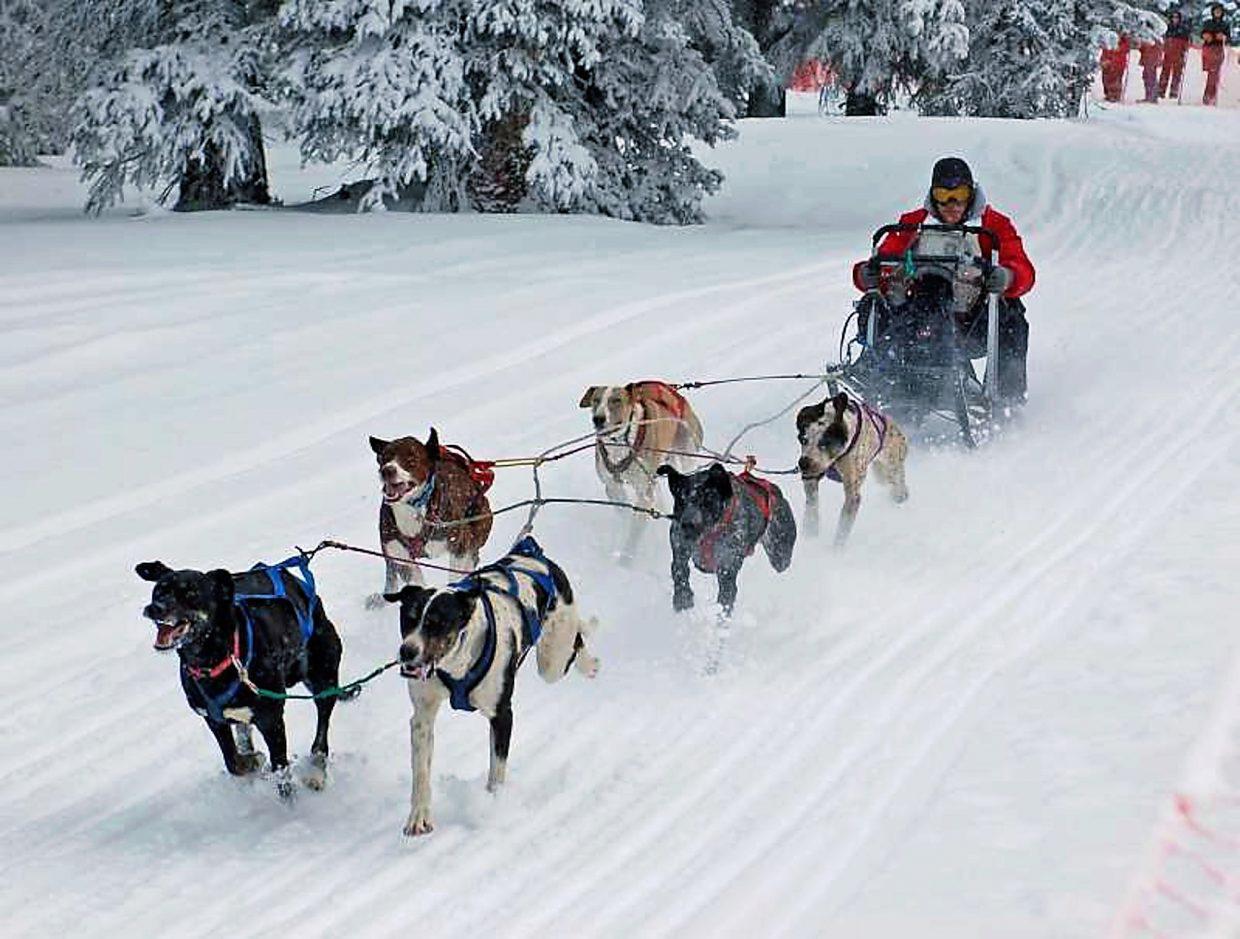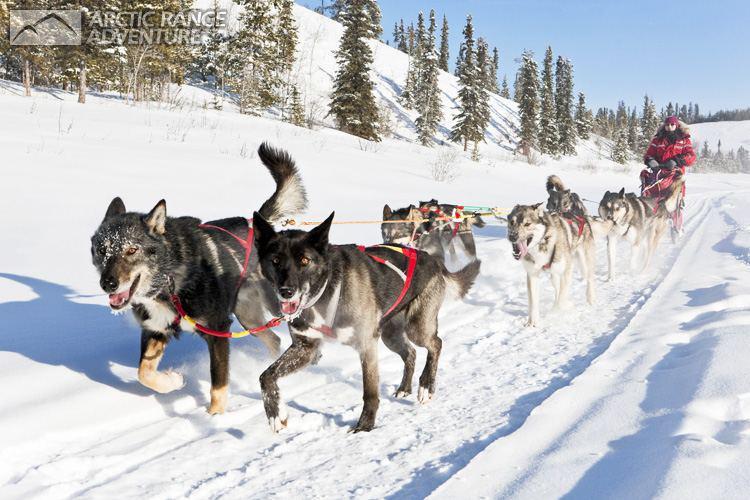The first image is the image on the left, the second image is the image on the right. Analyze the images presented: Is the assertion "The sled dog teams in the two images are heading in the same direction on a non-curved path." valid? Answer yes or no. Yes. The first image is the image on the left, the second image is the image on the right. For the images shown, is this caption "Both riders are wearing red jackets." true? Answer yes or no. Yes. 